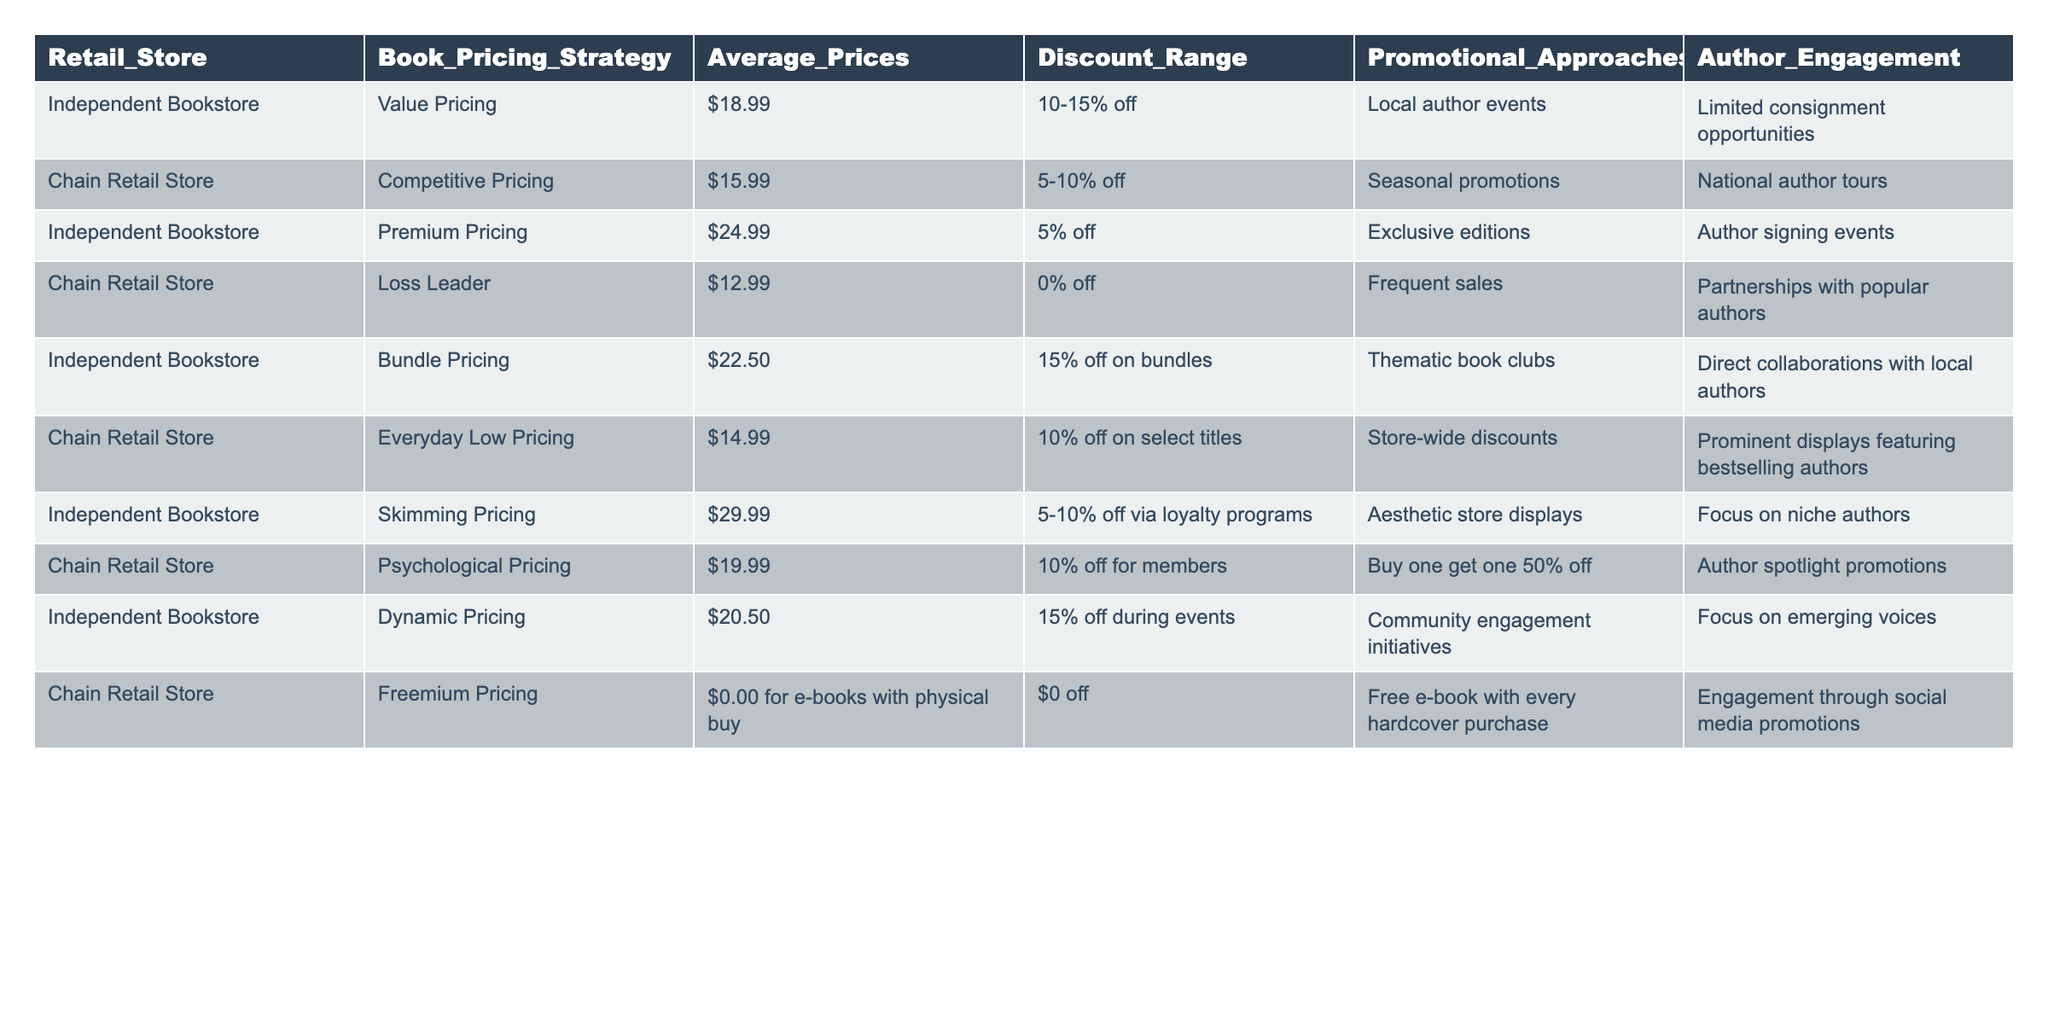What is the average price of books at independent bookstores? The average prices of books at independent bookstores from the table are $18.99, $24.99, $22.50, $29.99, and $20.50. To find the average, sum these values (18.99 + 24.99 + 22.50 + 29.99 + 20.50 = 116.97) and divide by the number of entries (5), which results in an average price of $23.39.
Answer: $23.39 Which pricing strategy is associated with the lowest average price for chain retail stores? From the table, the pricing strategies for chain retail stores are Competitive Pricing at $15.99, Loss Leader at $12.99, Everyday Low Pricing at $14.99, Psychological Pricing at $19.99, and Freemium Pricing at $0.00. The Loss Leader strategy has the lowest average price at $12.99.
Answer: Loss Leader Are independent bookstores more likely to use premium pricing compared to chain retail stores? The table shows independent bookstores using Premium Pricing at $24.99, while chain retail stores do not use Premium Pricing at all. Thus, independent bookstores are more likely to have a premium pricing strategy.
Answer: Yes What is the difference in average book price between the highest-priced independent bookstore strategy and the lowest-priced chain retail store strategy? The highest-priced independent strategy is Skimming Pricing at $29.99, while the lowest-priced chain strategy is Loss Leader at $12.99. The difference is calculated by subtracting the chain’s price from the independent’s price: $29.99 - $12.99 = $17.00.
Answer: $17.00 Which author engagement strategy is unique to independent bookstores compared to chain retail stores? The table lists several author engagement strategies for independent bookstores, including Local author events and Focus on niche authors, which are not mentioned for chain retail stores. In contrast, chain stores utilize National author tours and Partnerships with popular authors. The Local author events are unique to independent bookstores.
Answer: Local author events How many pricing strategies are listed for independent bookstores that offer a discount range of 10% or more? The table shows Independent Bookstore pricing strategies with discount ranges of 10-15% off (Value Pricing and Bundle Pricing) and 15% off during events (Dynamic Pricing). Thus, there are three strategies offering discounts of 10% or more: Value Pricing, Bundle Pricing, and Dynamic Pricing.
Answer: 3 Do chain retail stores have a strategy that offers e-books for free when a physical book is purchased? The Freemium Pricing strategy for chain retail stores states that customers receive a free e-book for every hardcover purchase, which confirms that this strategy does provide e-books for free.
Answer: Yes What is the average discount range for books sold at independent versus chain retail stores? The independent bookstore discount ranges average between 10-15%, 5% off, 15% off on bundles, and 5-10% off via loyalty programs, while chain store discount ranges average at 5-10%, 0%, 10% on select titles, and 10% for members. To compute the average discount, take the average of independent's range (about 12.5%) and chain's (about 6.5%), resulting in independent bookstores having a generally higher discount range than chains.
Answer: Independent bookstores have a higher average discount range 